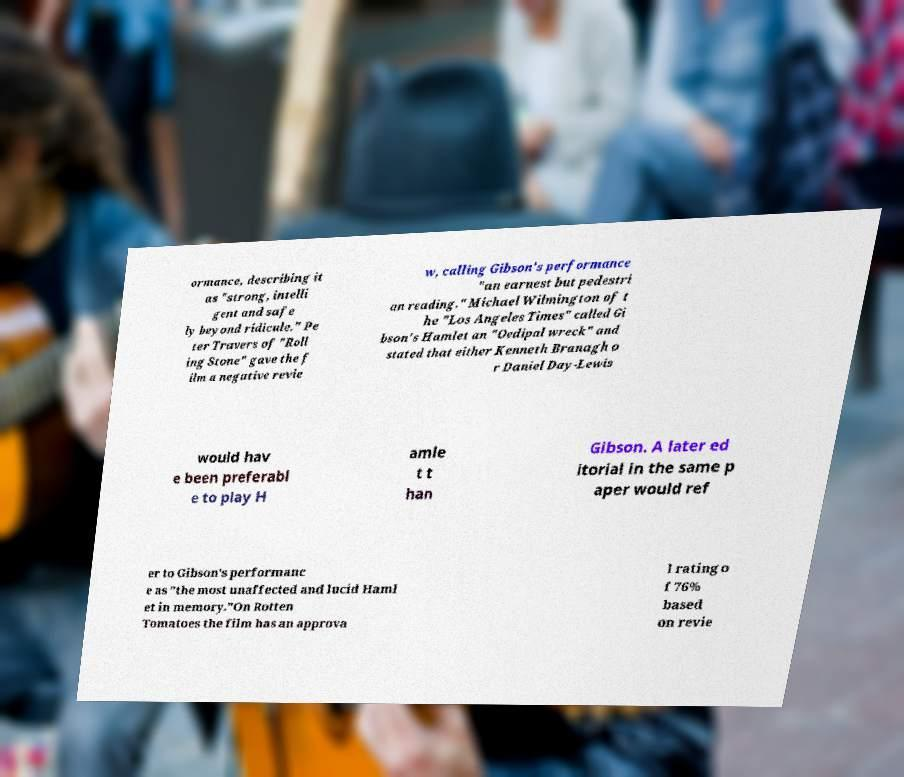For documentation purposes, I need the text within this image transcribed. Could you provide that? ormance, describing it as "strong, intelli gent and safe ly beyond ridicule." Pe ter Travers of "Roll ing Stone" gave the f ilm a negative revie w, calling Gibson's performance "an earnest but pedestri an reading." Michael Wilmington of t he "Los Angeles Times" called Gi bson's Hamlet an "Oedipal wreck" and stated that either Kenneth Branagh o r Daniel Day-Lewis would hav e been preferabl e to play H amle t t han Gibson. A later ed itorial in the same p aper would ref er to Gibson's performanc e as "the most unaffected and lucid Haml et in memory."On Rotten Tomatoes the film has an approva l rating o f 76% based on revie 